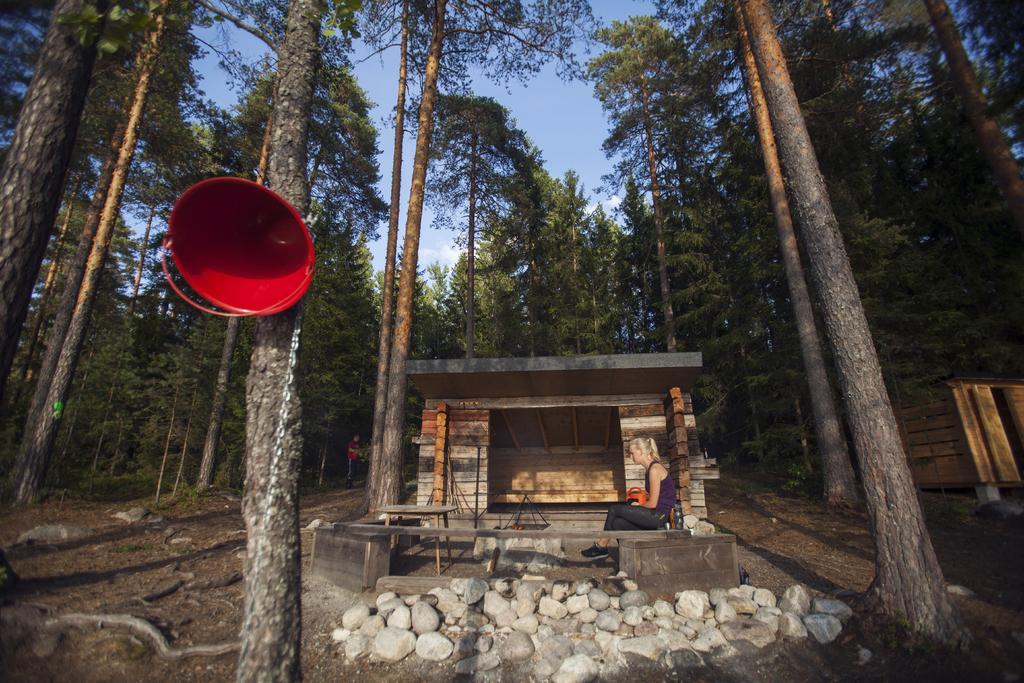Please provide a concise description of this image. Here I can see many trees. In the middle of the image I can see a wooden cabin. In front of this a woman is sitting on a bench facing towards the left side. On the ground, I can see the stones. On the right side there is another wooden cabin. On the left side, I can see a red color speaker which is attached to a tree trunk. At the top I can see the sky. 